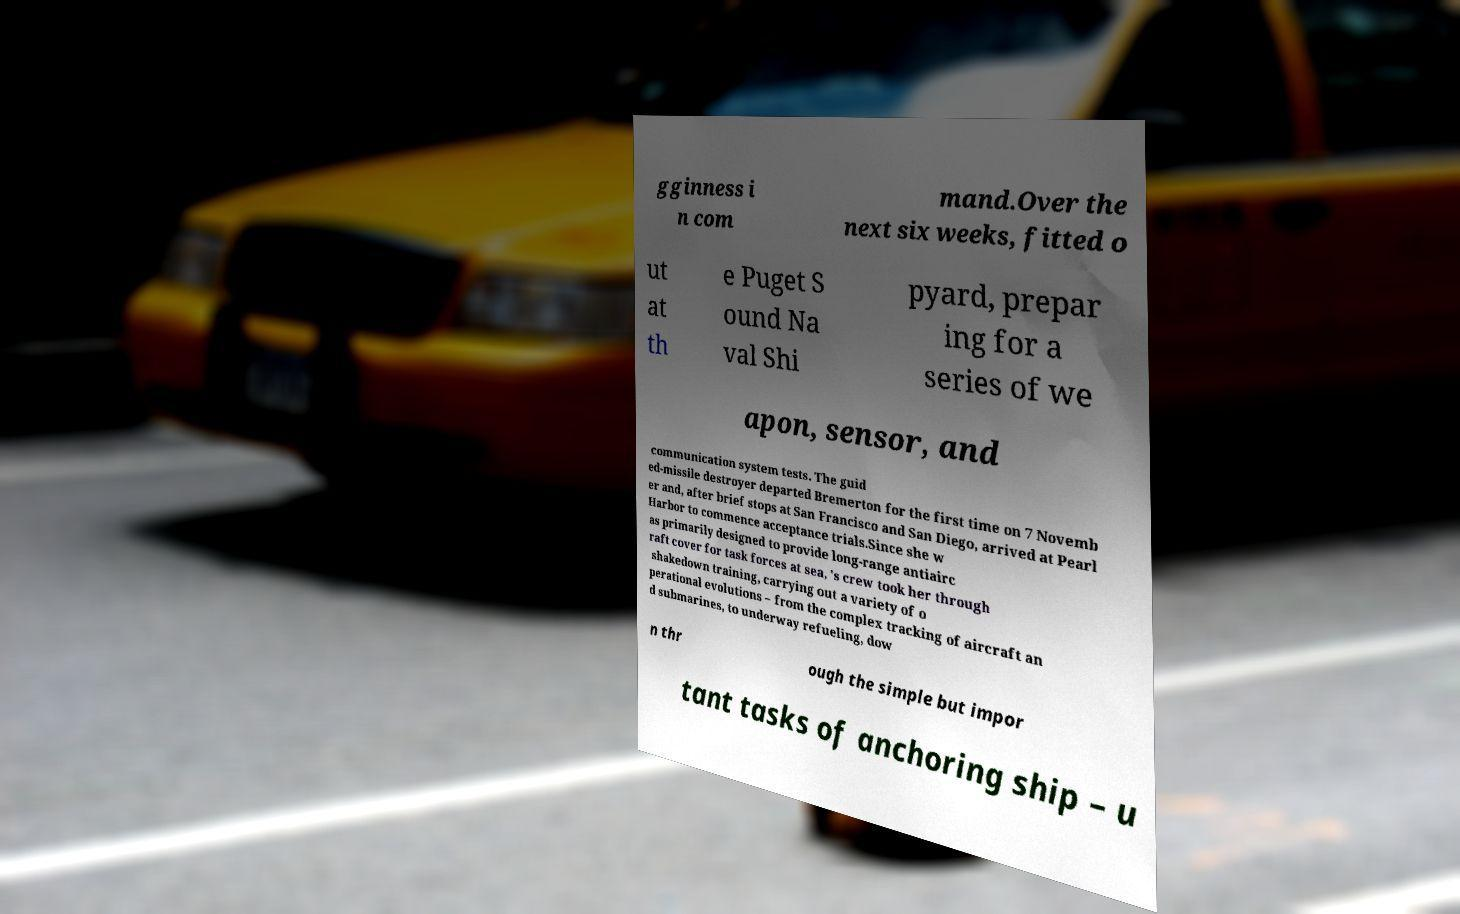Please identify and transcribe the text found in this image. gginness i n com mand.Over the next six weeks, fitted o ut at th e Puget S ound Na val Shi pyard, prepar ing for a series of we apon, sensor, and communication system tests. The guid ed-missile destroyer departed Bremerton for the first time on 7 Novemb er and, after brief stops at San Francisco and San Diego, arrived at Pearl Harbor to commence acceptance trials.Since she w as primarily designed to provide long-range antiairc raft cover for task forces at sea, 's crew took her through shakedown training, carrying out a variety of o perational evolutions – from the complex tracking of aircraft an d submarines, to underway refueling, dow n thr ough the simple but impor tant tasks of anchoring ship – u 